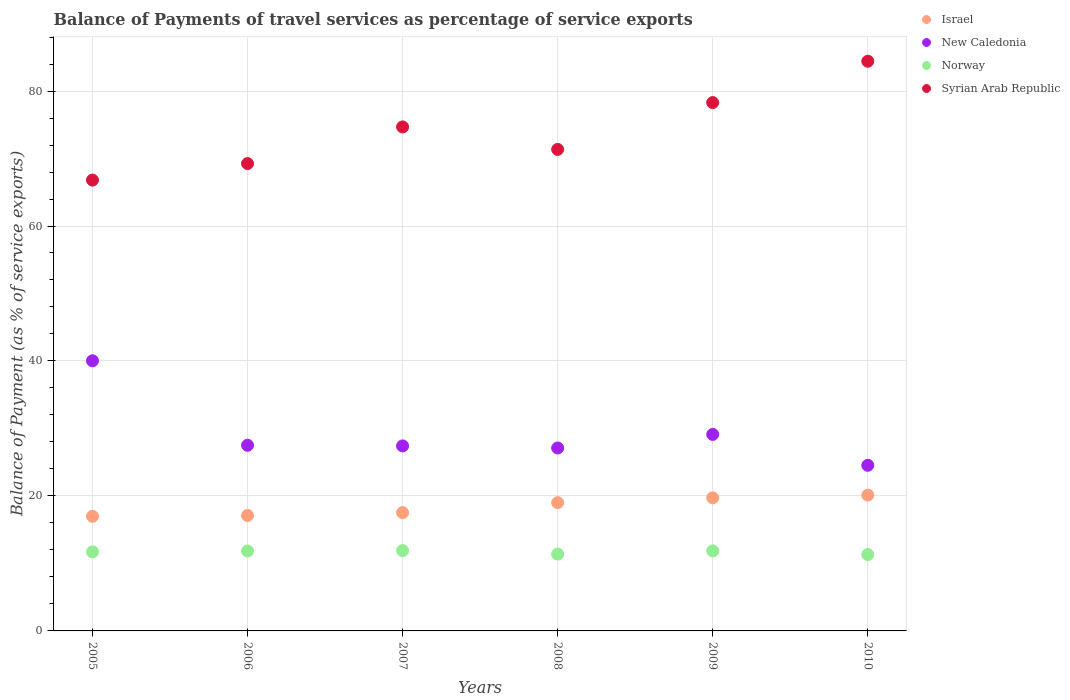How many different coloured dotlines are there?
Offer a very short reply. 4. What is the balance of payments of travel services in Syrian Arab Republic in 2005?
Keep it short and to the point. 66.8. Across all years, what is the maximum balance of payments of travel services in Norway?
Ensure brevity in your answer.  11.9. Across all years, what is the minimum balance of payments of travel services in Israel?
Provide a succinct answer. 16.98. In which year was the balance of payments of travel services in Syrian Arab Republic maximum?
Your answer should be compact. 2010. In which year was the balance of payments of travel services in Israel minimum?
Your response must be concise. 2005. What is the total balance of payments of travel services in New Caledonia in the graph?
Provide a succinct answer. 175.72. What is the difference between the balance of payments of travel services in Norway in 2009 and that in 2010?
Give a very brief answer. 0.54. What is the difference between the balance of payments of travel services in New Caledonia in 2006 and the balance of payments of travel services in Syrian Arab Republic in 2005?
Provide a short and direct response. -39.3. What is the average balance of payments of travel services in New Caledonia per year?
Your response must be concise. 29.29. In the year 2005, what is the difference between the balance of payments of travel services in Israel and balance of payments of travel services in Norway?
Keep it short and to the point. 5.27. What is the ratio of the balance of payments of travel services in Norway in 2006 to that in 2009?
Ensure brevity in your answer.  1. Is the balance of payments of travel services in New Caledonia in 2009 less than that in 2010?
Your answer should be very brief. No. Is the difference between the balance of payments of travel services in Israel in 2007 and 2009 greater than the difference between the balance of payments of travel services in Norway in 2007 and 2009?
Provide a short and direct response. No. What is the difference between the highest and the second highest balance of payments of travel services in Israel?
Your answer should be very brief. 0.41. What is the difference between the highest and the lowest balance of payments of travel services in Norway?
Offer a terse response. 0.59. Is the sum of the balance of payments of travel services in New Caledonia in 2007 and 2008 greater than the maximum balance of payments of travel services in Israel across all years?
Provide a succinct answer. Yes. Is it the case that in every year, the sum of the balance of payments of travel services in Syrian Arab Republic and balance of payments of travel services in Norway  is greater than the sum of balance of payments of travel services in New Caledonia and balance of payments of travel services in Israel?
Give a very brief answer. Yes. Does the balance of payments of travel services in Syrian Arab Republic monotonically increase over the years?
Make the answer very short. No. Is the balance of payments of travel services in Norway strictly greater than the balance of payments of travel services in Syrian Arab Republic over the years?
Offer a terse response. No. How many dotlines are there?
Offer a very short reply. 4. What is the difference between two consecutive major ticks on the Y-axis?
Offer a terse response. 20. Does the graph contain any zero values?
Make the answer very short. No. Does the graph contain grids?
Keep it short and to the point. Yes. How many legend labels are there?
Offer a very short reply. 4. How are the legend labels stacked?
Provide a succinct answer. Vertical. What is the title of the graph?
Give a very brief answer. Balance of Payments of travel services as percentage of service exports. What is the label or title of the Y-axis?
Offer a very short reply. Balance of Payment (as % of service exports). What is the Balance of Payment (as % of service exports) of Israel in 2005?
Provide a succinct answer. 16.98. What is the Balance of Payment (as % of service exports) of New Caledonia in 2005?
Ensure brevity in your answer.  40.03. What is the Balance of Payment (as % of service exports) of Norway in 2005?
Make the answer very short. 11.71. What is the Balance of Payment (as % of service exports) in Syrian Arab Republic in 2005?
Provide a short and direct response. 66.8. What is the Balance of Payment (as % of service exports) of Israel in 2006?
Your answer should be very brief. 17.11. What is the Balance of Payment (as % of service exports) in New Caledonia in 2006?
Your response must be concise. 27.51. What is the Balance of Payment (as % of service exports) of Norway in 2006?
Ensure brevity in your answer.  11.84. What is the Balance of Payment (as % of service exports) of Syrian Arab Republic in 2006?
Your response must be concise. 69.25. What is the Balance of Payment (as % of service exports) in Israel in 2007?
Provide a short and direct response. 17.53. What is the Balance of Payment (as % of service exports) in New Caledonia in 2007?
Provide a succinct answer. 27.42. What is the Balance of Payment (as % of service exports) of Norway in 2007?
Your answer should be compact. 11.9. What is the Balance of Payment (as % of service exports) in Syrian Arab Republic in 2007?
Make the answer very short. 74.68. What is the Balance of Payment (as % of service exports) in Israel in 2008?
Provide a short and direct response. 19.01. What is the Balance of Payment (as % of service exports) of New Caledonia in 2008?
Your response must be concise. 27.11. What is the Balance of Payment (as % of service exports) in Norway in 2008?
Ensure brevity in your answer.  11.38. What is the Balance of Payment (as % of service exports) of Syrian Arab Republic in 2008?
Offer a terse response. 71.35. What is the Balance of Payment (as % of service exports) of Israel in 2009?
Keep it short and to the point. 19.72. What is the Balance of Payment (as % of service exports) in New Caledonia in 2009?
Make the answer very short. 29.12. What is the Balance of Payment (as % of service exports) of Norway in 2009?
Make the answer very short. 11.86. What is the Balance of Payment (as % of service exports) in Syrian Arab Republic in 2009?
Your answer should be very brief. 78.29. What is the Balance of Payment (as % of service exports) of Israel in 2010?
Offer a terse response. 20.13. What is the Balance of Payment (as % of service exports) in New Caledonia in 2010?
Provide a succinct answer. 24.54. What is the Balance of Payment (as % of service exports) in Norway in 2010?
Offer a terse response. 11.32. What is the Balance of Payment (as % of service exports) in Syrian Arab Republic in 2010?
Provide a succinct answer. 84.41. Across all years, what is the maximum Balance of Payment (as % of service exports) in Israel?
Provide a succinct answer. 20.13. Across all years, what is the maximum Balance of Payment (as % of service exports) of New Caledonia?
Offer a terse response. 40.03. Across all years, what is the maximum Balance of Payment (as % of service exports) of Norway?
Ensure brevity in your answer.  11.9. Across all years, what is the maximum Balance of Payment (as % of service exports) in Syrian Arab Republic?
Make the answer very short. 84.41. Across all years, what is the minimum Balance of Payment (as % of service exports) in Israel?
Keep it short and to the point. 16.98. Across all years, what is the minimum Balance of Payment (as % of service exports) of New Caledonia?
Ensure brevity in your answer.  24.54. Across all years, what is the minimum Balance of Payment (as % of service exports) in Norway?
Your answer should be compact. 11.32. Across all years, what is the minimum Balance of Payment (as % of service exports) in Syrian Arab Republic?
Provide a short and direct response. 66.8. What is the total Balance of Payment (as % of service exports) in Israel in the graph?
Provide a short and direct response. 110.48. What is the total Balance of Payment (as % of service exports) of New Caledonia in the graph?
Offer a very short reply. 175.72. What is the total Balance of Payment (as % of service exports) in Norway in the graph?
Your answer should be very brief. 70.03. What is the total Balance of Payment (as % of service exports) in Syrian Arab Republic in the graph?
Ensure brevity in your answer.  444.79. What is the difference between the Balance of Payment (as % of service exports) in Israel in 2005 and that in 2006?
Keep it short and to the point. -0.13. What is the difference between the Balance of Payment (as % of service exports) in New Caledonia in 2005 and that in 2006?
Your response must be concise. 12.52. What is the difference between the Balance of Payment (as % of service exports) of Norway in 2005 and that in 2006?
Make the answer very short. -0.13. What is the difference between the Balance of Payment (as % of service exports) of Syrian Arab Republic in 2005 and that in 2006?
Ensure brevity in your answer.  -2.45. What is the difference between the Balance of Payment (as % of service exports) of Israel in 2005 and that in 2007?
Your response must be concise. -0.55. What is the difference between the Balance of Payment (as % of service exports) of New Caledonia in 2005 and that in 2007?
Keep it short and to the point. 12.61. What is the difference between the Balance of Payment (as % of service exports) in Norway in 2005 and that in 2007?
Your response must be concise. -0.19. What is the difference between the Balance of Payment (as % of service exports) in Syrian Arab Republic in 2005 and that in 2007?
Your answer should be very brief. -7.88. What is the difference between the Balance of Payment (as % of service exports) in Israel in 2005 and that in 2008?
Offer a very short reply. -2.03. What is the difference between the Balance of Payment (as % of service exports) of New Caledonia in 2005 and that in 2008?
Your answer should be very brief. 12.92. What is the difference between the Balance of Payment (as % of service exports) of Norway in 2005 and that in 2008?
Provide a short and direct response. 0.33. What is the difference between the Balance of Payment (as % of service exports) of Syrian Arab Republic in 2005 and that in 2008?
Your answer should be compact. -4.54. What is the difference between the Balance of Payment (as % of service exports) of Israel in 2005 and that in 2009?
Your answer should be compact. -2.74. What is the difference between the Balance of Payment (as % of service exports) in New Caledonia in 2005 and that in 2009?
Your response must be concise. 10.91. What is the difference between the Balance of Payment (as % of service exports) in Norway in 2005 and that in 2009?
Give a very brief answer. -0.15. What is the difference between the Balance of Payment (as % of service exports) of Syrian Arab Republic in 2005 and that in 2009?
Make the answer very short. -11.48. What is the difference between the Balance of Payment (as % of service exports) in Israel in 2005 and that in 2010?
Provide a short and direct response. -3.14. What is the difference between the Balance of Payment (as % of service exports) of New Caledonia in 2005 and that in 2010?
Offer a very short reply. 15.49. What is the difference between the Balance of Payment (as % of service exports) in Norway in 2005 and that in 2010?
Provide a succinct answer. 0.39. What is the difference between the Balance of Payment (as % of service exports) in Syrian Arab Republic in 2005 and that in 2010?
Ensure brevity in your answer.  -17.61. What is the difference between the Balance of Payment (as % of service exports) of Israel in 2006 and that in 2007?
Offer a terse response. -0.42. What is the difference between the Balance of Payment (as % of service exports) of New Caledonia in 2006 and that in 2007?
Your answer should be very brief. 0.09. What is the difference between the Balance of Payment (as % of service exports) of Norway in 2006 and that in 2007?
Give a very brief answer. -0.06. What is the difference between the Balance of Payment (as % of service exports) of Syrian Arab Republic in 2006 and that in 2007?
Your answer should be very brief. -5.43. What is the difference between the Balance of Payment (as % of service exports) in Israel in 2006 and that in 2008?
Offer a very short reply. -1.9. What is the difference between the Balance of Payment (as % of service exports) in New Caledonia in 2006 and that in 2008?
Offer a very short reply. 0.4. What is the difference between the Balance of Payment (as % of service exports) of Norway in 2006 and that in 2008?
Your response must be concise. 0.46. What is the difference between the Balance of Payment (as % of service exports) of Syrian Arab Republic in 2006 and that in 2008?
Your answer should be compact. -2.09. What is the difference between the Balance of Payment (as % of service exports) in Israel in 2006 and that in 2009?
Offer a very short reply. -2.61. What is the difference between the Balance of Payment (as % of service exports) of New Caledonia in 2006 and that in 2009?
Your answer should be compact. -1.61. What is the difference between the Balance of Payment (as % of service exports) in Norway in 2006 and that in 2009?
Your answer should be very brief. -0.02. What is the difference between the Balance of Payment (as % of service exports) of Syrian Arab Republic in 2006 and that in 2009?
Offer a terse response. -9.03. What is the difference between the Balance of Payment (as % of service exports) of Israel in 2006 and that in 2010?
Offer a terse response. -3.01. What is the difference between the Balance of Payment (as % of service exports) in New Caledonia in 2006 and that in 2010?
Offer a terse response. 2.97. What is the difference between the Balance of Payment (as % of service exports) in Norway in 2006 and that in 2010?
Offer a very short reply. 0.53. What is the difference between the Balance of Payment (as % of service exports) in Syrian Arab Republic in 2006 and that in 2010?
Provide a succinct answer. -15.16. What is the difference between the Balance of Payment (as % of service exports) of Israel in 2007 and that in 2008?
Offer a very short reply. -1.48. What is the difference between the Balance of Payment (as % of service exports) of New Caledonia in 2007 and that in 2008?
Provide a succinct answer. 0.31. What is the difference between the Balance of Payment (as % of service exports) in Norway in 2007 and that in 2008?
Your answer should be very brief. 0.52. What is the difference between the Balance of Payment (as % of service exports) of Syrian Arab Republic in 2007 and that in 2008?
Keep it short and to the point. 3.33. What is the difference between the Balance of Payment (as % of service exports) in Israel in 2007 and that in 2009?
Offer a very short reply. -2.19. What is the difference between the Balance of Payment (as % of service exports) in New Caledonia in 2007 and that in 2009?
Give a very brief answer. -1.7. What is the difference between the Balance of Payment (as % of service exports) of Norway in 2007 and that in 2009?
Your answer should be very brief. 0.04. What is the difference between the Balance of Payment (as % of service exports) of Syrian Arab Republic in 2007 and that in 2009?
Provide a short and direct response. -3.6. What is the difference between the Balance of Payment (as % of service exports) of Israel in 2007 and that in 2010?
Offer a very short reply. -2.6. What is the difference between the Balance of Payment (as % of service exports) in New Caledonia in 2007 and that in 2010?
Offer a terse response. 2.88. What is the difference between the Balance of Payment (as % of service exports) in Norway in 2007 and that in 2010?
Give a very brief answer. 0.59. What is the difference between the Balance of Payment (as % of service exports) of Syrian Arab Republic in 2007 and that in 2010?
Provide a succinct answer. -9.73. What is the difference between the Balance of Payment (as % of service exports) of Israel in 2008 and that in 2009?
Keep it short and to the point. -0.71. What is the difference between the Balance of Payment (as % of service exports) of New Caledonia in 2008 and that in 2009?
Offer a very short reply. -2.01. What is the difference between the Balance of Payment (as % of service exports) in Norway in 2008 and that in 2009?
Your answer should be compact. -0.48. What is the difference between the Balance of Payment (as % of service exports) in Syrian Arab Republic in 2008 and that in 2009?
Ensure brevity in your answer.  -6.94. What is the difference between the Balance of Payment (as % of service exports) of Israel in 2008 and that in 2010?
Your answer should be compact. -1.12. What is the difference between the Balance of Payment (as % of service exports) in New Caledonia in 2008 and that in 2010?
Offer a terse response. 2.57. What is the difference between the Balance of Payment (as % of service exports) in Norway in 2008 and that in 2010?
Offer a very short reply. 0.07. What is the difference between the Balance of Payment (as % of service exports) of Syrian Arab Republic in 2008 and that in 2010?
Ensure brevity in your answer.  -13.07. What is the difference between the Balance of Payment (as % of service exports) in Israel in 2009 and that in 2010?
Keep it short and to the point. -0.41. What is the difference between the Balance of Payment (as % of service exports) in New Caledonia in 2009 and that in 2010?
Your answer should be compact. 4.58. What is the difference between the Balance of Payment (as % of service exports) in Norway in 2009 and that in 2010?
Make the answer very short. 0.54. What is the difference between the Balance of Payment (as % of service exports) of Syrian Arab Republic in 2009 and that in 2010?
Provide a succinct answer. -6.13. What is the difference between the Balance of Payment (as % of service exports) in Israel in 2005 and the Balance of Payment (as % of service exports) in New Caledonia in 2006?
Offer a very short reply. -10.53. What is the difference between the Balance of Payment (as % of service exports) in Israel in 2005 and the Balance of Payment (as % of service exports) in Norway in 2006?
Keep it short and to the point. 5.14. What is the difference between the Balance of Payment (as % of service exports) of Israel in 2005 and the Balance of Payment (as % of service exports) of Syrian Arab Republic in 2006?
Provide a short and direct response. -52.27. What is the difference between the Balance of Payment (as % of service exports) in New Caledonia in 2005 and the Balance of Payment (as % of service exports) in Norway in 2006?
Offer a very short reply. 28.18. What is the difference between the Balance of Payment (as % of service exports) of New Caledonia in 2005 and the Balance of Payment (as % of service exports) of Syrian Arab Republic in 2006?
Keep it short and to the point. -29.23. What is the difference between the Balance of Payment (as % of service exports) of Norway in 2005 and the Balance of Payment (as % of service exports) of Syrian Arab Republic in 2006?
Offer a terse response. -57.54. What is the difference between the Balance of Payment (as % of service exports) in Israel in 2005 and the Balance of Payment (as % of service exports) in New Caledonia in 2007?
Keep it short and to the point. -10.43. What is the difference between the Balance of Payment (as % of service exports) in Israel in 2005 and the Balance of Payment (as % of service exports) in Norway in 2007?
Provide a short and direct response. 5.08. What is the difference between the Balance of Payment (as % of service exports) of Israel in 2005 and the Balance of Payment (as % of service exports) of Syrian Arab Republic in 2007?
Your answer should be compact. -57.7. What is the difference between the Balance of Payment (as % of service exports) in New Caledonia in 2005 and the Balance of Payment (as % of service exports) in Norway in 2007?
Keep it short and to the point. 28.12. What is the difference between the Balance of Payment (as % of service exports) in New Caledonia in 2005 and the Balance of Payment (as % of service exports) in Syrian Arab Republic in 2007?
Offer a very short reply. -34.66. What is the difference between the Balance of Payment (as % of service exports) of Norway in 2005 and the Balance of Payment (as % of service exports) of Syrian Arab Republic in 2007?
Provide a short and direct response. -62.97. What is the difference between the Balance of Payment (as % of service exports) in Israel in 2005 and the Balance of Payment (as % of service exports) in New Caledonia in 2008?
Your answer should be compact. -10.12. What is the difference between the Balance of Payment (as % of service exports) of Israel in 2005 and the Balance of Payment (as % of service exports) of Norway in 2008?
Offer a terse response. 5.6. What is the difference between the Balance of Payment (as % of service exports) of Israel in 2005 and the Balance of Payment (as % of service exports) of Syrian Arab Republic in 2008?
Make the answer very short. -54.36. What is the difference between the Balance of Payment (as % of service exports) in New Caledonia in 2005 and the Balance of Payment (as % of service exports) in Norway in 2008?
Your response must be concise. 28.64. What is the difference between the Balance of Payment (as % of service exports) in New Caledonia in 2005 and the Balance of Payment (as % of service exports) in Syrian Arab Republic in 2008?
Offer a terse response. -31.32. What is the difference between the Balance of Payment (as % of service exports) of Norway in 2005 and the Balance of Payment (as % of service exports) of Syrian Arab Republic in 2008?
Provide a short and direct response. -59.64. What is the difference between the Balance of Payment (as % of service exports) of Israel in 2005 and the Balance of Payment (as % of service exports) of New Caledonia in 2009?
Your answer should be very brief. -12.14. What is the difference between the Balance of Payment (as % of service exports) in Israel in 2005 and the Balance of Payment (as % of service exports) in Norway in 2009?
Your answer should be very brief. 5.12. What is the difference between the Balance of Payment (as % of service exports) in Israel in 2005 and the Balance of Payment (as % of service exports) in Syrian Arab Republic in 2009?
Offer a terse response. -61.3. What is the difference between the Balance of Payment (as % of service exports) of New Caledonia in 2005 and the Balance of Payment (as % of service exports) of Norway in 2009?
Give a very brief answer. 28.16. What is the difference between the Balance of Payment (as % of service exports) in New Caledonia in 2005 and the Balance of Payment (as % of service exports) in Syrian Arab Republic in 2009?
Offer a terse response. -38.26. What is the difference between the Balance of Payment (as % of service exports) of Norway in 2005 and the Balance of Payment (as % of service exports) of Syrian Arab Republic in 2009?
Offer a very short reply. -66.57. What is the difference between the Balance of Payment (as % of service exports) of Israel in 2005 and the Balance of Payment (as % of service exports) of New Caledonia in 2010?
Give a very brief answer. -7.56. What is the difference between the Balance of Payment (as % of service exports) of Israel in 2005 and the Balance of Payment (as % of service exports) of Norway in 2010?
Provide a succinct answer. 5.66. What is the difference between the Balance of Payment (as % of service exports) of Israel in 2005 and the Balance of Payment (as % of service exports) of Syrian Arab Republic in 2010?
Your answer should be very brief. -67.43. What is the difference between the Balance of Payment (as % of service exports) of New Caledonia in 2005 and the Balance of Payment (as % of service exports) of Norway in 2010?
Offer a very short reply. 28.71. What is the difference between the Balance of Payment (as % of service exports) in New Caledonia in 2005 and the Balance of Payment (as % of service exports) in Syrian Arab Republic in 2010?
Your answer should be very brief. -44.39. What is the difference between the Balance of Payment (as % of service exports) in Norway in 2005 and the Balance of Payment (as % of service exports) in Syrian Arab Republic in 2010?
Make the answer very short. -72.7. What is the difference between the Balance of Payment (as % of service exports) of Israel in 2006 and the Balance of Payment (as % of service exports) of New Caledonia in 2007?
Your answer should be very brief. -10.3. What is the difference between the Balance of Payment (as % of service exports) of Israel in 2006 and the Balance of Payment (as % of service exports) of Norway in 2007?
Your answer should be very brief. 5.21. What is the difference between the Balance of Payment (as % of service exports) of Israel in 2006 and the Balance of Payment (as % of service exports) of Syrian Arab Republic in 2007?
Your answer should be very brief. -57.57. What is the difference between the Balance of Payment (as % of service exports) of New Caledonia in 2006 and the Balance of Payment (as % of service exports) of Norway in 2007?
Keep it short and to the point. 15.6. What is the difference between the Balance of Payment (as % of service exports) of New Caledonia in 2006 and the Balance of Payment (as % of service exports) of Syrian Arab Republic in 2007?
Your response must be concise. -47.17. What is the difference between the Balance of Payment (as % of service exports) of Norway in 2006 and the Balance of Payment (as % of service exports) of Syrian Arab Republic in 2007?
Your answer should be very brief. -62.84. What is the difference between the Balance of Payment (as % of service exports) in Israel in 2006 and the Balance of Payment (as % of service exports) in New Caledonia in 2008?
Offer a terse response. -9.99. What is the difference between the Balance of Payment (as % of service exports) of Israel in 2006 and the Balance of Payment (as % of service exports) of Norway in 2008?
Provide a short and direct response. 5.73. What is the difference between the Balance of Payment (as % of service exports) in Israel in 2006 and the Balance of Payment (as % of service exports) in Syrian Arab Republic in 2008?
Provide a succinct answer. -54.23. What is the difference between the Balance of Payment (as % of service exports) of New Caledonia in 2006 and the Balance of Payment (as % of service exports) of Norway in 2008?
Give a very brief answer. 16.12. What is the difference between the Balance of Payment (as % of service exports) of New Caledonia in 2006 and the Balance of Payment (as % of service exports) of Syrian Arab Republic in 2008?
Your answer should be very brief. -43.84. What is the difference between the Balance of Payment (as % of service exports) in Norway in 2006 and the Balance of Payment (as % of service exports) in Syrian Arab Republic in 2008?
Ensure brevity in your answer.  -59.5. What is the difference between the Balance of Payment (as % of service exports) in Israel in 2006 and the Balance of Payment (as % of service exports) in New Caledonia in 2009?
Keep it short and to the point. -12.01. What is the difference between the Balance of Payment (as % of service exports) in Israel in 2006 and the Balance of Payment (as % of service exports) in Norway in 2009?
Make the answer very short. 5.25. What is the difference between the Balance of Payment (as % of service exports) of Israel in 2006 and the Balance of Payment (as % of service exports) of Syrian Arab Republic in 2009?
Your answer should be very brief. -61.17. What is the difference between the Balance of Payment (as % of service exports) of New Caledonia in 2006 and the Balance of Payment (as % of service exports) of Norway in 2009?
Your response must be concise. 15.64. What is the difference between the Balance of Payment (as % of service exports) in New Caledonia in 2006 and the Balance of Payment (as % of service exports) in Syrian Arab Republic in 2009?
Provide a short and direct response. -50.78. What is the difference between the Balance of Payment (as % of service exports) in Norway in 2006 and the Balance of Payment (as % of service exports) in Syrian Arab Republic in 2009?
Provide a short and direct response. -66.44. What is the difference between the Balance of Payment (as % of service exports) of Israel in 2006 and the Balance of Payment (as % of service exports) of New Caledonia in 2010?
Offer a terse response. -7.43. What is the difference between the Balance of Payment (as % of service exports) in Israel in 2006 and the Balance of Payment (as % of service exports) in Norway in 2010?
Your answer should be compact. 5.79. What is the difference between the Balance of Payment (as % of service exports) in Israel in 2006 and the Balance of Payment (as % of service exports) in Syrian Arab Republic in 2010?
Offer a terse response. -67.3. What is the difference between the Balance of Payment (as % of service exports) of New Caledonia in 2006 and the Balance of Payment (as % of service exports) of Norway in 2010?
Your answer should be very brief. 16.19. What is the difference between the Balance of Payment (as % of service exports) in New Caledonia in 2006 and the Balance of Payment (as % of service exports) in Syrian Arab Republic in 2010?
Give a very brief answer. -56.91. What is the difference between the Balance of Payment (as % of service exports) in Norway in 2006 and the Balance of Payment (as % of service exports) in Syrian Arab Republic in 2010?
Keep it short and to the point. -72.57. What is the difference between the Balance of Payment (as % of service exports) of Israel in 2007 and the Balance of Payment (as % of service exports) of New Caledonia in 2008?
Offer a very short reply. -9.58. What is the difference between the Balance of Payment (as % of service exports) of Israel in 2007 and the Balance of Payment (as % of service exports) of Norway in 2008?
Provide a succinct answer. 6.14. What is the difference between the Balance of Payment (as % of service exports) in Israel in 2007 and the Balance of Payment (as % of service exports) in Syrian Arab Republic in 2008?
Your answer should be compact. -53.82. What is the difference between the Balance of Payment (as % of service exports) of New Caledonia in 2007 and the Balance of Payment (as % of service exports) of Norway in 2008?
Provide a succinct answer. 16.03. What is the difference between the Balance of Payment (as % of service exports) in New Caledonia in 2007 and the Balance of Payment (as % of service exports) in Syrian Arab Republic in 2008?
Keep it short and to the point. -43.93. What is the difference between the Balance of Payment (as % of service exports) of Norway in 2007 and the Balance of Payment (as % of service exports) of Syrian Arab Republic in 2008?
Offer a very short reply. -59.44. What is the difference between the Balance of Payment (as % of service exports) of Israel in 2007 and the Balance of Payment (as % of service exports) of New Caledonia in 2009?
Provide a short and direct response. -11.59. What is the difference between the Balance of Payment (as % of service exports) of Israel in 2007 and the Balance of Payment (as % of service exports) of Norway in 2009?
Give a very brief answer. 5.66. What is the difference between the Balance of Payment (as % of service exports) of Israel in 2007 and the Balance of Payment (as % of service exports) of Syrian Arab Republic in 2009?
Your answer should be compact. -60.76. What is the difference between the Balance of Payment (as % of service exports) of New Caledonia in 2007 and the Balance of Payment (as % of service exports) of Norway in 2009?
Give a very brief answer. 15.55. What is the difference between the Balance of Payment (as % of service exports) of New Caledonia in 2007 and the Balance of Payment (as % of service exports) of Syrian Arab Republic in 2009?
Your response must be concise. -50.87. What is the difference between the Balance of Payment (as % of service exports) of Norway in 2007 and the Balance of Payment (as % of service exports) of Syrian Arab Republic in 2009?
Provide a succinct answer. -66.38. What is the difference between the Balance of Payment (as % of service exports) in Israel in 2007 and the Balance of Payment (as % of service exports) in New Caledonia in 2010?
Make the answer very short. -7.01. What is the difference between the Balance of Payment (as % of service exports) in Israel in 2007 and the Balance of Payment (as % of service exports) in Norway in 2010?
Keep it short and to the point. 6.21. What is the difference between the Balance of Payment (as % of service exports) in Israel in 2007 and the Balance of Payment (as % of service exports) in Syrian Arab Republic in 2010?
Offer a terse response. -66.89. What is the difference between the Balance of Payment (as % of service exports) in New Caledonia in 2007 and the Balance of Payment (as % of service exports) in Norway in 2010?
Offer a terse response. 16.1. What is the difference between the Balance of Payment (as % of service exports) in New Caledonia in 2007 and the Balance of Payment (as % of service exports) in Syrian Arab Republic in 2010?
Your response must be concise. -57. What is the difference between the Balance of Payment (as % of service exports) of Norway in 2007 and the Balance of Payment (as % of service exports) of Syrian Arab Republic in 2010?
Make the answer very short. -72.51. What is the difference between the Balance of Payment (as % of service exports) in Israel in 2008 and the Balance of Payment (as % of service exports) in New Caledonia in 2009?
Offer a terse response. -10.11. What is the difference between the Balance of Payment (as % of service exports) in Israel in 2008 and the Balance of Payment (as % of service exports) in Norway in 2009?
Provide a short and direct response. 7.15. What is the difference between the Balance of Payment (as % of service exports) of Israel in 2008 and the Balance of Payment (as % of service exports) of Syrian Arab Republic in 2009?
Provide a succinct answer. -59.28. What is the difference between the Balance of Payment (as % of service exports) in New Caledonia in 2008 and the Balance of Payment (as % of service exports) in Norway in 2009?
Your response must be concise. 15.24. What is the difference between the Balance of Payment (as % of service exports) of New Caledonia in 2008 and the Balance of Payment (as % of service exports) of Syrian Arab Republic in 2009?
Provide a short and direct response. -51.18. What is the difference between the Balance of Payment (as % of service exports) of Norway in 2008 and the Balance of Payment (as % of service exports) of Syrian Arab Republic in 2009?
Your answer should be compact. -66.9. What is the difference between the Balance of Payment (as % of service exports) of Israel in 2008 and the Balance of Payment (as % of service exports) of New Caledonia in 2010?
Make the answer very short. -5.53. What is the difference between the Balance of Payment (as % of service exports) of Israel in 2008 and the Balance of Payment (as % of service exports) of Norway in 2010?
Make the answer very short. 7.69. What is the difference between the Balance of Payment (as % of service exports) of Israel in 2008 and the Balance of Payment (as % of service exports) of Syrian Arab Republic in 2010?
Give a very brief answer. -65.4. What is the difference between the Balance of Payment (as % of service exports) in New Caledonia in 2008 and the Balance of Payment (as % of service exports) in Norway in 2010?
Provide a succinct answer. 15.79. What is the difference between the Balance of Payment (as % of service exports) of New Caledonia in 2008 and the Balance of Payment (as % of service exports) of Syrian Arab Republic in 2010?
Provide a short and direct response. -57.31. What is the difference between the Balance of Payment (as % of service exports) of Norway in 2008 and the Balance of Payment (as % of service exports) of Syrian Arab Republic in 2010?
Keep it short and to the point. -73.03. What is the difference between the Balance of Payment (as % of service exports) of Israel in 2009 and the Balance of Payment (as % of service exports) of New Caledonia in 2010?
Keep it short and to the point. -4.82. What is the difference between the Balance of Payment (as % of service exports) of Israel in 2009 and the Balance of Payment (as % of service exports) of Norway in 2010?
Provide a succinct answer. 8.4. What is the difference between the Balance of Payment (as % of service exports) of Israel in 2009 and the Balance of Payment (as % of service exports) of Syrian Arab Republic in 2010?
Provide a short and direct response. -64.69. What is the difference between the Balance of Payment (as % of service exports) of New Caledonia in 2009 and the Balance of Payment (as % of service exports) of Norway in 2010?
Your answer should be very brief. 17.8. What is the difference between the Balance of Payment (as % of service exports) in New Caledonia in 2009 and the Balance of Payment (as % of service exports) in Syrian Arab Republic in 2010?
Offer a terse response. -55.29. What is the difference between the Balance of Payment (as % of service exports) in Norway in 2009 and the Balance of Payment (as % of service exports) in Syrian Arab Republic in 2010?
Your answer should be very brief. -72.55. What is the average Balance of Payment (as % of service exports) of Israel per year?
Ensure brevity in your answer.  18.41. What is the average Balance of Payment (as % of service exports) in New Caledonia per year?
Make the answer very short. 29.29. What is the average Balance of Payment (as % of service exports) of Norway per year?
Your answer should be compact. 11.67. What is the average Balance of Payment (as % of service exports) in Syrian Arab Republic per year?
Your response must be concise. 74.13. In the year 2005, what is the difference between the Balance of Payment (as % of service exports) in Israel and Balance of Payment (as % of service exports) in New Caledonia?
Give a very brief answer. -23.04. In the year 2005, what is the difference between the Balance of Payment (as % of service exports) of Israel and Balance of Payment (as % of service exports) of Norway?
Keep it short and to the point. 5.27. In the year 2005, what is the difference between the Balance of Payment (as % of service exports) of Israel and Balance of Payment (as % of service exports) of Syrian Arab Republic?
Ensure brevity in your answer.  -49.82. In the year 2005, what is the difference between the Balance of Payment (as % of service exports) of New Caledonia and Balance of Payment (as % of service exports) of Norway?
Make the answer very short. 28.31. In the year 2005, what is the difference between the Balance of Payment (as % of service exports) of New Caledonia and Balance of Payment (as % of service exports) of Syrian Arab Republic?
Your answer should be very brief. -26.78. In the year 2005, what is the difference between the Balance of Payment (as % of service exports) of Norway and Balance of Payment (as % of service exports) of Syrian Arab Republic?
Provide a succinct answer. -55.09. In the year 2006, what is the difference between the Balance of Payment (as % of service exports) in Israel and Balance of Payment (as % of service exports) in New Caledonia?
Your answer should be compact. -10.4. In the year 2006, what is the difference between the Balance of Payment (as % of service exports) in Israel and Balance of Payment (as % of service exports) in Norway?
Give a very brief answer. 5.27. In the year 2006, what is the difference between the Balance of Payment (as % of service exports) of Israel and Balance of Payment (as % of service exports) of Syrian Arab Republic?
Your answer should be very brief. -52.14. In the year 2006, what is the difference between the Balance of Payment (as % of service exports) in New Caledonia and Balance of Payment (as % of service exports) in Norway?
Provide a succinct answer. 15.66. In the year 2006, what is the difference between the Balance of Payment (as % of service exports) of New Caledonia and Balance of Payment (as % of service exports) of Syrian Arab Republic?
Your answer should be compact. -41.75. In the year 2006, what is the difference between the Balance of Payment (as % of service exports) in Norway and Balance of Payment (as % of service exports) in Syrian Arab Republic?
Provide a short and direct response. -57.41. In the year 2007, what is the difference between the Balance of Payment (as % of service exports) in Israel and Balance of Payment (as % of service exports) in New Caledonia?
Offer a terse response. -9.89. In the year 2007, what is the difference between the Balance of Payment (as % of service exports) of Israel and Balance of Payment (as % of service exports) of Norway?
Keep it short and to the point. 5.62. In the year 2007, what is the difference between the Balance of Payment (as % of service exports) of Israel and Balance of Payment (as % of service exports) of Syrian Arab Republic?
Give a very brief answer. -57.15. In the year 2007, what is the difference between the Balance of Payment (as % of service exports) of New Caledonia and Balance of Payment (as % of service exports) of Norway?
Provide a succinct answer. 15.51. In the year 2007, what is the difference between the Balance of Payment (as % of service exports) of New Caledonia and Balance of Payment (as % of service exports) of Syrian Arab Republic?
Your answer should be compact. -47.27. In the year 2007, what is the difference between the Balance of Payment (as % of service exports) of Norway and Balance of Payment (as % of service exports) of Syrian Arab Republic?
Your answer should be very brief. -62.78. In the year 2008, what is the difference between the Balance of Payment (as % of service exports) in Israel and Balance of Payment (as % of service exports) in New Caledonia?
Offer a very short reply. -8.1. In the year 2008, what is the difference between the Balance of Payment (as % of service exports) in Israel and Balance of Payment (as % of service exports) in Norway?
Your answer should be compact. 7.62. In the year 2008, what is the difference between the Balance of Payment (as % of service exports) of Israel and Balance of Payment (as % of service exports) of Syrian Arab Republic?
Offer a terse response. -52.34. In the year 2008, what is the difference between the Balance of Payment (as % of service exports) of New Caledonia and Balance of Payment (as % of service exports) of Norway?
Offer a very short reply. 15.72. In the year 2008, what is the difference between the Balance of Payment (as % of service exports) in New Caledonia and Balance of Payment (as % of service exports) in Syrian Arab Republic?
Offer a terse response. -44.24. In the year 2008, what is the difference between the Balance of Payment (as % of service exports) in Norway and Balance of Payment (as % of service exports) in Syrian Arab Republic?
Offer a terse response. -59.96. In the year 2009, what is the difference between the Balance of Payment (as % of service exports) in Israel and Balance of Payment (as % of service exports) in New Caledonia?
Make the answer very short. -9.4. In the year 2009, what is the difference between the Balance of Payment (as % of service exports) in Israel and Balance of Payment (as % of service exports) in Norway?
Provide a short and direct response. 7.86. In the year 2009, what is the difference between the Balance of Payment (as % of service exports) of Israel and Balance of Payment (as % of service exports) of Syrian Arab Republic?
Your response must be concise. -58.57. In the year 2009, what is the difference between the Balance of Payment (as % of service exports) in New Caledonia and Balance of Payment (as % of service exports) in Norway?
Provide a short and direct response. 17.26. In the year 2009, what is the difference between the Balance of Payment (as % of service exports) of New Caledonia and Balance of Payment (as % of service exports) of Syrian Arab Republic?
Offer a terse response. -49.17. In the year 2009, what is the difference between the Balance of Payment (as % of service exports) in Norway and Balance of Payment (as % of service exports) in Syrian Arab Republic?
Provide a short and direct response. -66.42. In the year 2010, what is the difference between the Balance of Payment (as % of service exports) in Israel and Balance of Payment (as % of service exports) in New Caledonia?
Offer a very short reply. -4.41. In the year 2010, what is the difference between the Balance of Payment (as % of service exports) in Israel and Balance of Payment (as % of service exports) in Norway?
Make the answer very short. 8.81. In the year 2010, what is the difference between the Balance of Payment (as % of service exports) of Israel and Balance of Payment (as % of service exports) of Syrian Arab Republic?
Ensure brevity in your answer.  -64.29. In the year 2010, what is the difference between the Balance of Payment (as % of service exports) in New Caledonia and Balance of Payment (as % of service exports) in Norway?
Offer a terse response. 13.22. In the year 2010, what is the difference between the Balance of Payment (as % of service exports) of New Caledonia and Balance of Payment (as % of service exports) of Syrian Arab Republic?
Provide a short and direct response. -59.87. In the year 2010, what is the difference between the Balance of Payment (as % of service exports) of Norway and Balance of Payment (as % of service exports) of Syrian Arab Republic?
Your response must be concise. -73.09. What is the ratio of the Balance of Payment (as % of service exports) of New Caledonia in 2005 to that in 2006?
Make the answer very short. 1.46. What is the ratio of the Balance of Payment (as % of service exports) in Norway in 2005 to that in 2006?
Your response must be concise. 0.99. What is the ratio of the Balance of Payment (as % of service exports) of Syrian Arab Republic in 2005 to that in 2006?
Keep it short and to the point. 0.96. What is the ratio of the Balance of Payment (as % of service exports) of Israel in 2005 to that in 2007?
Your answer should be compact. 0.97. What is the ratio of the Balance of Payment (as % of service exports) of New Caledonia in 2005 to that in 2007?
Provide a short and direct response. 1.46. What is the ratio of the Balance of Payment (as % of service exports) of Norway in 2005 to that in 2007?
Provide a short and direct response. 0.98. What is the ratio of the Balance of Payment (as % of service exports) of Syrian Arab Republic in 2005 to that in 2007?
Your response must be concise. 0.89. What is the ratio of the Balance of Payment (as % of service exports) of Israel in 2005 to that in 2008?
Your response must be concise. 0.89. What is the ratio of the Balance of Payment (as % of service exports) of New Caledonia in 2005 to that in 2008?
Offer a very short reply. 1.48. What is the ratio of the Balance of Payment (as % of service exports) of Norway in 2005 to that in 2008?
Your answer should be compact. 1.03. What is the ratio of the Balance of Payment (as % of service exports) of Syrian Arab Republic in 2005 to that in 2008?
Your response must be concise. 0.94. What is the ratio of the Balance of Payment (as % of service exports) of Israel in 2005 to that in 2009?
Make the answer very short. 0.86. What is the ratio of the Balance of Payment (as % of service exports) of New Caledonia in 2005 to that in 2009?
Ensure brevity in your answer.  1.37. What is the ratio of the Balance of Payment (as % of service exports) of Norway in 2005 to that in 2009?
Provide a short and direct response. 0.99. What is the ratio of the Balance of Payment (as % of service exports) of Syrian Arab Republic in 2005 to that in 2009?
Ensure brevity in your answer.  0.85. What is the ratio of the Balance of Payment (as % of service exports) of Israel in 2005 to that in 2010?
Provide a short and direct response. 0.84. What is the ratio of the Balance of Payment (as % of service exports) in New Caledonia in 2005 to that in 2010?
Give a very brief answer. 1.63. What is the ratio of the Balance of Payment (as % of service exports) in Norway in 2005 to that in 2010?
Offer a very short reply. 1.03. What is the ratio of the Balance of Payment (as % of service exports) of Syrian Arab Republic in 2005 to that in 2010?
Keep it short and to the point. 0.79. What is the ratio of the Balance of Payment (as % of service exports) of Israel in 2006 to that in 2007?
Keep it short and to the point. 0.98. What is the ratio of the Balance of Payment (as % of service exports) in New Caledonia in 2006 to that in 2007?
Keep it short and to the point. 1. What is the ratio of the Balance of Payment (as % of service exports) of Norway in 2006 to that in 2007?
Offer a terse response. 0.99. What is the ratio of the Balance of Payment (as % of service exports) in Syrian Arab Republic in 2006 to that in 2007?
Keep it short and to the point. 0.93. What is the ratio of the Balance of Payment (as % of service exports) in Israel in 2006 to that in 2008?
Keep it short and to the point. 0.9. What is the ratio of the Balance of Payment (as % of service exports) in New Caledonia in 2006 to that in 2008?
Keep it short and to the point. 1.01. What is the ratio of the Balance of Payment (as % of service exports) in Norway in 2006 to that in 2008?
Make the answer very short. 1.04. What is the ratio of the Balance of Payment (as % of service exports) in Syrian Arab Republic in 2006 to that in 2008?
Your response must be concise. 0.97. What is the ratio of the Balance of Payment (as % of service exports) of Israel in 2006 to that in 2009?
Your answer should be compact. 0.87. What is the ratio of the Balance of Payment (as % of service exports) in New Caledonia in 2006 to that in 2009?
Offer a terse response. 0.94. What is the ratio of the Balance of Payment (as % of service exports) in Norway in 2006 to that in 2009?
Your answer should be very brief. 1. What is the ratio of the Balance of Payment (as % of service exports) of Syrian Arab Republic in 2006 to that in 2009?
Offer a very short reply. 0.88. What is the ratio of the Balance of Payment (as % of service exports) in Israel in 2006 to that in 2010?
Your answer should be very brief. 0.85. What is the ratio of the Balance of Payment (as % of service exports) of New Caledonia in 2006 to that in 2010?
Ensure brevity in your answer.  1.12. What is the ratio of the Balance of Payment (as % of service exports) in Norway in 2006 to that in 2010?
Give a very brief answer. 1.05. What is the ratio of the Balance of Payment (as % of service exports) in Syrian Arab Republic in 2006 to that in 2010?
Offer a very short reply. 0.82. What is the ratio of the Balance of Payment (as % of service exports) in Israel in 2007 to that in 2008?
Offer a very short reply. 0.92. What is the ratio of the Balance of Payment (as % of service exports) of New Caledonia in 2007 to that in 2008?
Your answer should be very brief. 1.01. What is the ratio of the Balance of Payment (as % of service exports) in Norway in 2007 to that in 2008?
Offer a terse response. 1.05. What is the ratio of the Balance of Payment (as % of service exports) in Syrian Arab Republic in 2007 to that in 2008?
Ensure brevity in your answer.  1.05. What is the ratio of the Balance of Payment (as % of service exports) in Israel in 2007 to that in 2009?
Your response must be concise. 0.89. What is the ratio of the Balance of Payment (as % of service exports) of New Caledonia in 2007 to that in 2009?
Make the answer very short. 0.94. What is the ratio of the Balance of Payment (as % of service exports) in Norway in 2007 to that in 2009?
Your answer should be very brief. 1. What is the ratio of the Balance of Payment (as % of service exports) in Syrian Arab Republic in 2007 to that in 2009?
Ensure brevity in your answer.  0.95. What is the ratio of the Balance of Payment (as % of service exports) of Israel in 2007 to that in 2010?
Your response must be concise. 0.87. What is the ratio of the Balance of Payment (as % of service exports) in New Caledonia in 2007 to that in 2010?
Your response must be concise. 1.12. What is the ratio of the Balance of Payment (as % of service exports) in Norway in 2007 to that in 2010?
Your answer should be compact. 1.05. What is the ratio of the Balance of Payment (as % of service exports) in Syrian Arab Republic in 2007 to that in 2010?
Ensure brevity in your answer.  0.88. What is the ratio of the Balance of Payment (as % of service exports) in Israel in 2008 to that in 2009?
Give a very brief answer. 0.96. What is the ratio of the Balance of Payment (as % of service exports) of New Caledonia in 2008 to that in 2009?
Your response must be concise. 0.93. What is the ratio of the Balance of Payment (as % of service exports) in Norway in 2008 to that in 2009?
Your answer should be very brief. 0.96. What is the ratio of the Balance of Payment (as % of service exports) in Syrian Arab Republic in 2008 to that in 2009?
Give a very brief answer. 0.91. What is the ratio of the Balance of Payment (as % of service exports) of Israel in 2008 to that in 2010?
Provide a short and direct response. 0.94. What is the ratio of the Balance of Payment (as % of service exports) in New Caledonia in 2008 to that in 2010?
Your answer should be very brief. 1.1. What is the ratio of the Balance of Payment (as % of service exports) of Syrian Arab Republic in 2008 to that in 2010?
Your answer should be compact. 0.85. What is the ratio of the Balance of Payment (as % of service exports) in Israel in 2009 to that in 2010?
Your response must be concise. 0.98. What is the ratio of the Balance of Payment (as % of service exports) of New Caledonia in 2009 to that in 2010?
Offer a terse response. 1.19. What is the ratio of the Balance of Payment (as % of service exports) in Norway in 2009 to that in 2010?
Provide a succinct answer. 1.05. What is the ratio of the Balance of Payment (as % of service exports) in Syrian Arab Republic in 2009 to that in 2010?
Provide a succinct answer. 0.93. What is the difference between the highest and the second highest Balance of Payment (as % of service exports) in Israel?
Make the answer very short. 0.41. What is the difference between the highest and the second highest Balance of Payment (as % of service exports) in New Caledonia?
Provide a succinct answer. 10.91. What is the difference between the highest and the second highest Balance of Payment (as % of service exports) of Norway?
Make the answer very short. 0.04. What is the difference between the highest and the second highest Balance of Payment (as % of service exports) of Syrian Arab Republic?
Ensure brevity in your answer.  6.13. What is the difference between the highest and the lowest Balance of Payment (as % of service exports) of Israel?
Your answer should be compact. 3.14. What is the difference between the highest and the lowest Balance of Payment (as % of service exports) of New Caledonia?
Your response must be concise. 15.49. What is the difference between the highest and the lowest Balance of Payment (as % of service exports) of Norway?
Make the answer very short. 0.59. What is the difference between the highest and the lowest Balance of Payment (as % of service exports) in Syrian Arab Republic?
Give a very brief answer. 17.61. 